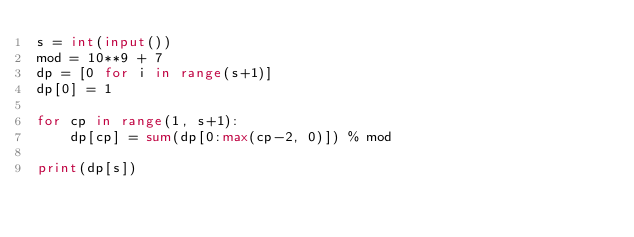<code> <loc_0><loc_0><loc_500><loc_500><_Python_>s = int(input())
mod = 10**9 + 7
dp = [0 for i in range(s+1)]
dp[0] = 1

for cp in range(1, s+1):
    dp[cp] = sum(dp[0:max(cp-2, 0)]) % mod

print(dp[s])</code> 